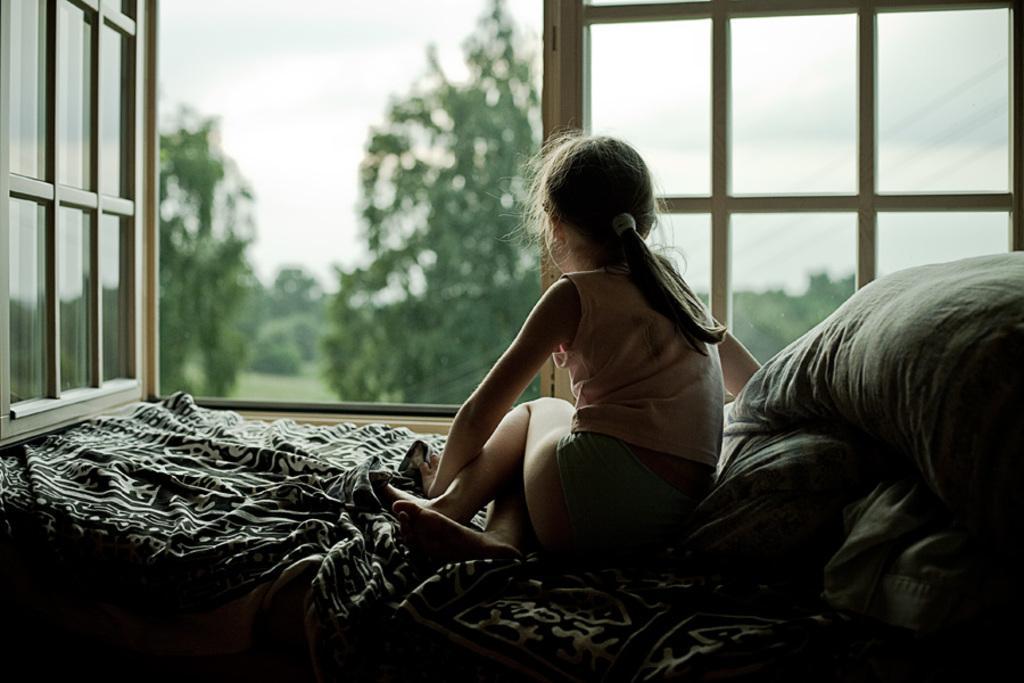How would you summarize this image in a sentence or two? In this image there is a girl sitting on the bed having blanket and few pillows are on it. Behind there is a window from which few trees on the grassland and sky are visible. 